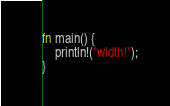Convert code to text. <code><loc_0><loc_0><loc_500><loc_500><_Rust_>fn main() {
    println!("width!");
}
</code> 